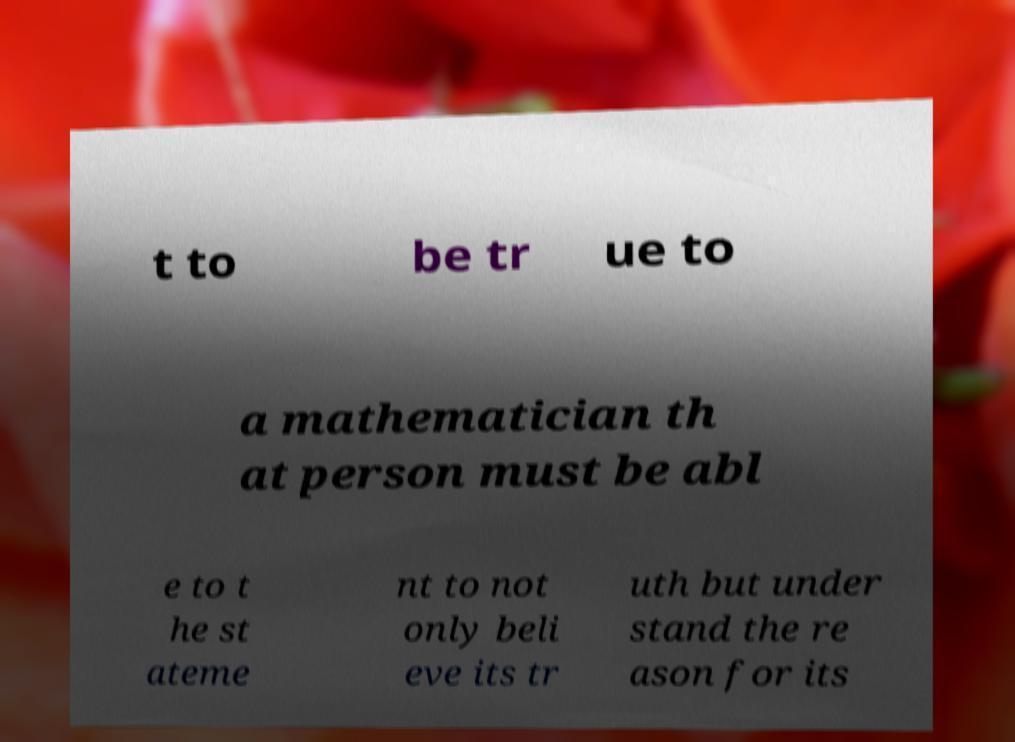What messages or text are displayed in this image? I need them in a readable, typed format. t to be tr ue to a mathematician th at person must be abl e to t he st ateme nt to not only beli eve its tr uth but under stand the re ason for its 